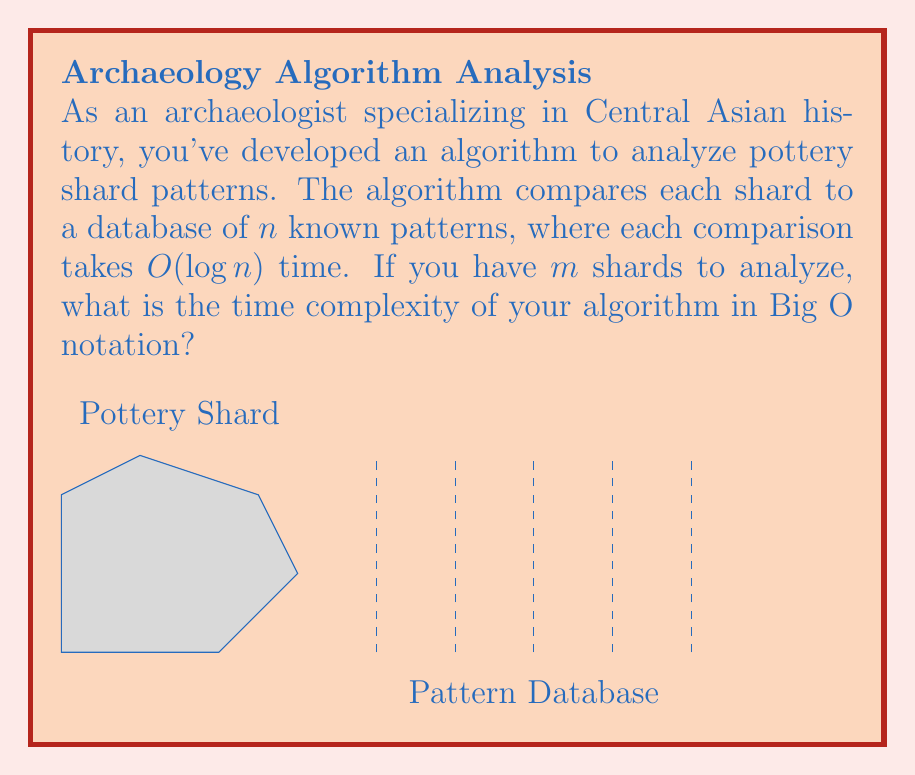Can you answer this question? Let's break this down step-by-step:

1) For each shard, we need to compare it against all $n$ patterns in the database.

2) Each comparison takes $O(\log n)$ time.

3) Therefore, for a single shard, the time complexity is:
   $$O(n \cdot \log n)$$

4) We have $m$ shards to analyze, and we perform this process for each shard.

5) This means we multiply the complexity for a single shard by $m$:
   $$O(m \cdot n \cdot \log n)$$

6) In Big O notation, we typically express this as:
   $$O(mn \log n)$$

This represents the worst-case time complexity of the algorithm, where we need to compare each of the $m$ shards against all $n$ patterns in the database.
Answer: $O(mn \log n)$ 